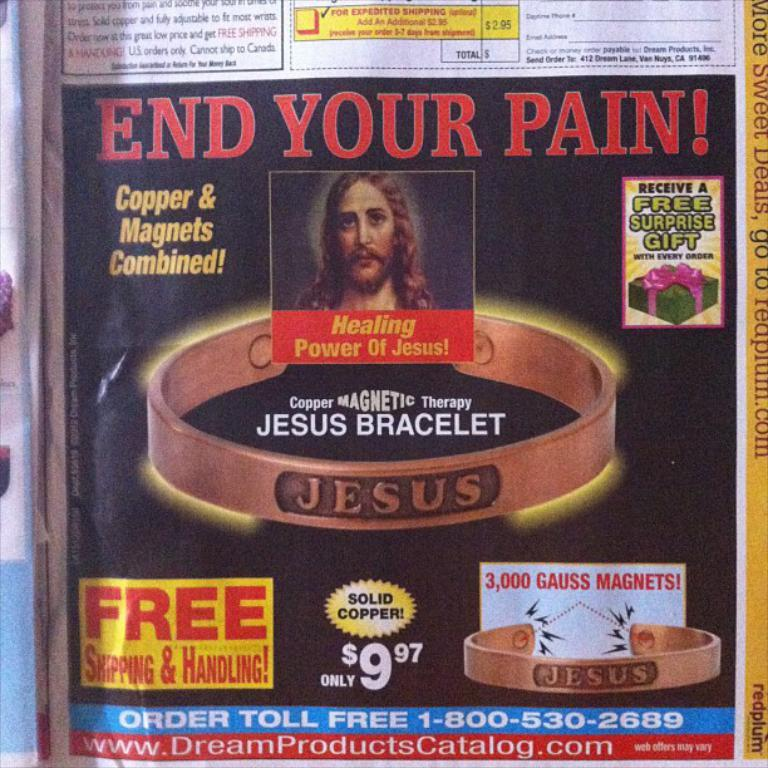What is the main subject of the image? There is a picture of a man in the image. What other objects can be seen in the image? There are bracelets in the image. What is unique about the bracelets? The bracelets have writing on them. Is there any text or information in the image? Yes, there is some information in the image. Can you tell me how many bones the toad in the image has? There is no toad present in the image, so it is not possible to determine the number of bones it might have. 